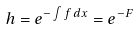Convert formula to latex. <formula><loc_0><loc_0><loc_500><loc_500>h = e ^ { - \int f \, d x } = e ^ { - F }</formula> 